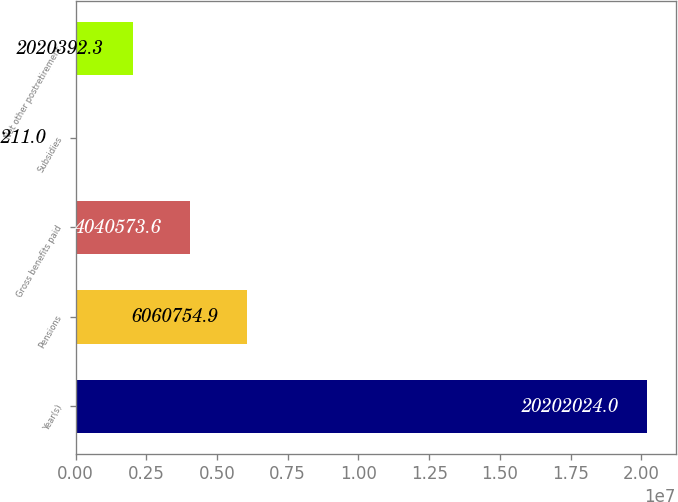Convert chart to OTSL. <chart><loc_0><loc_0><loc_500><loc_500><bar_chart><fcel>Year(s)<fcel>Pensions<fcel>Gross benefits paid<fcel>Subsidies<fcel>Net other postretirement<nl><fcel>2.0202e+07<fcel>6.06075e+06<fcel>4.04057e+06<fcel>211<fcel>2.02039e+06<nl></chart> 